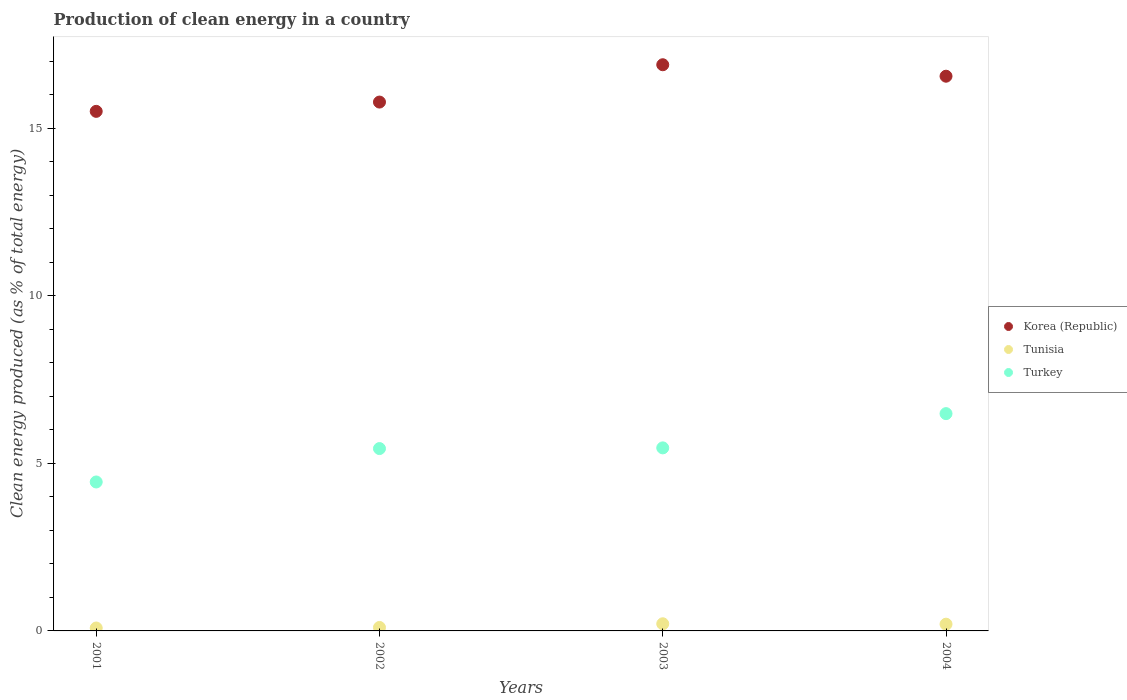How many different coloured dotlines are there?
Offer a terse response. 3. Is the number of dotlines equal to the number of legend labels?
Your response must be concise. Yes. What is the percentage of clean energy produced in Turkey in 2002?
Make the answer very short. 5.44. Across all years, what is the maximum percentage of clean energy produced in Turkey?
Offer a very short reply. 6.48. Across all years, what is the minimum percentage of clean energy produced in Korea (Republic)?
Offer a terse response. 15.5. In which year was the percentage of clean energy produced in Tunisia minimum?
Keep it short and to the point. 2001. What is the total percentage of clean energy produced in Turkey in the graph?
Keep it short and to the point. 21.83. What is the difference between the percentage of clean energy produced in Korea (Republic) in 2002 and that in 2004?
Make the answer very short. -0.77. What is the difference between the percentage of clean energy produced in Turkey in 2002 and the percentage of clean energy produced in Tunisia in 2001?
Provide a succinct answer. 5.35. What is the average percentage of clean energy produced in Tunisia per year?
Ensure brevity in your answer.  0.15. In the year 2003, what is the difference between the percentage of clean energy produced in Turkey and percentage of clean energy produced in Korea (Republic)?
Your answer should be compact. -11.43. What is the ratio of the percentage of clean energy produced in Turkey in 2001 to that in 2002?
Your answer should be very brief. 0.82. Is the percentage of clean energy produced in Tunisia in 2001 less than that in 2004?
Make the answer very short. Yes. What is the difference between the highest and the second highest percentage of clean energy produced in Turkey?
Offer a terse response. 1.02. What is the difference between the highest and the lowest percentage of clean energy produced in Tunisia?
Give a very brief answer. 0.13. Does the percentage of clean energy produced in Tunisia monotonically increase over the years?
Ensure brevity in your answer.  No. Is the percentage of clean energy produced in Turkey strictly greater than the percentage of clean energy produced in Korea (Republic) over the years?
Ensure brevity in your answer.  No. Is the percentage of clean energy produced in Tunisia strictly less than the percentage of clean energy produced in Turkey over the years?
Give a very brief answer. Yes. How many dotlines are there?
Give a very brief answer. 3. What is the title of the graph?
Give a very brief answer. Production of clean energy in a country. What is the label or title of the X-axis?
Provide a succinct answer. Years. What is the label or title of the Y-axis?
Provide a succinct answer. Clean energy produced (as % of total energy). What is the Clean energy produced (as % of total energy) of Korea (Republic) in 2001?
Provide a short and direct response. 15.5. What is the Clean energy produced (as % of total energy) in Tunisia in 2001?
Give a very brief answer. 0.09. What is the Clean energy produced (as % of total energy) in Turkey in 2001?
Offer a very short reply. 4.44. What is the Clean energy produced (as % of total energy) of Korea (Republic) in 2002?
Make the answer very short. 15.78. What is the Clean energy produced (as % of total energy) in Tunisia in 2002?
Offer a terse response. 0.1. What is the Clean energy produced (as % of total energy) of Turkey in 2002?
Your answer should be compact. 5.44. What is the Clean energy produced (as % of total energy) of Korea (Republic) in 2003?
Offer a terse response. 16.89. What is the Clean energy produced (as % of total energy) in Tunisia in 2003?
Provide a short and direct response. 0.21. What is the Clean energy produced (as % of total energy) in Turkey in 2003?
Offer a very short reply. 5.46. What is the Clean energy produced (as % of total energy) of Korea (Republic) in 2004?
Make the answer very short. 16.55. What is the Clean energy produced (as % of total energy) of Tunisia in 2004?
Offer a very short reply. 0.2. What is the Clean energy produced (as % of total energy) of Turkey in 2004?
Your answer should be very brief. 6.48. Across all years, what is the maximum Clean energy produced (as % of total energy) in Korea (Republic)?
Offer a very short reply. 16.89. Across all years, what is the maximum Clean energy produced (as % of total energy) of Tunisia?
Keep it short and to the point. 0.21. Across all years, what is the maximum Clean energy produced (as % of total energy) in Turkey?
Offer a very short reply. 6.48. Across all years, what is the minimum Clean energy produced (as % of total energy) in Korea (Republic)?
Give a very brief answer. 15.5. Across all years, what is the minimum Clean energy produced (as % of total energy) of Tunisia?
Your answer should be very brief. 0.09. Across all years, what is the minimum Clean energy produced (as % of total energy) of Turkey?
Offer a very short reply. 4.44. What is the total Clean energy produced (as % of total energy) of Korea (Republic) in the graph?
Give a very brief answer. 64.73. What is the total Clean energy produced (as % of total energy) in Tunisia in the graph?
Offer a very short reply. 0.6. What is the total Clean energy produced (as % of total energy) of Turkey in the graph?
Your answer should be compact. 21.83. What is the difference between the Clean energy produced (as % of total energy) in Korea (Republic) in 2001 and that in 2002?
Your answer should be very brief. -0.28. What is the difference between the Clean energy produced (as % of total energy) in Tunisia in 2001 and that in 2002?
Provide a succinct answer. -0.02. What is the difference between the Clean energy produced (as % of total energy) of Turkey in 2001 and that in 2002?
Ensure brevity in your answer.  -1. What is the difference between the Clean energy produced (as % of total energy) of Korea (Republic) in 2001 and that in 2003?
Your answer should be very brief. -1.39. What is the difference between the Clean energy produced (as % of total energy) in Tunisia in 2001 and that in 2003?
Give a very brief answer. -0.13. What is the difference between the Clean energy produced (as % of total energy) in Turkey in 2001 and that in 2003?
Your response must be concise. -1.02. What is the difference between the Clean energy produced (as % of total energy) in Korea (Republic) in 2001 and that in 2004?
Ensure brevity in your answer.  -1.05. What is the difference between the Clean energy produced (as % of total energy) in Tunisia in 2001 and that in 2004?
Keep it short and to the point. -0.11. What is the difference between the Clean energy produced (as % of total energy) of Turkey in 2001 and that in 2004?
Ensure brevity in your answer.  -2.04. What is the difference between the Clean energy produced (as % of total energy) in Korea (Republic) in 2002 and that in 2003?
Give a very brief answer. -1.11. What is the difference between the Clean energy produced (as % of total energy) in Tunisia in 2002 and that in 2003?
Offer a terse response. -0.11. What is the difference between the Clean energy produced (as % of total energy) of Turkey in 2002 and that in 2003?
Offer a terse response. -0.02. What is the difference between the Clean energy produced (as % of total energy) in Korea (Republic) in 2002 and that in 2004?
Keep it short and to the point. -0.77. What is the difference between the Clean energy produced (as % of total energy) in Tunisia in 2002 and that in 2004?
Ensure brevity in your answer.  -0.1. What is the difference between the Clean energy produced (as % of total energy) in Turkey in 2002 and that in 2004?
Keep it short and to the point. -1.04. What is the difference between the Clean energy produced (as % of total energy) in Korea (Republic) in 2003 and that in 2004?
Provide a succinct answer. 0.34. What is the difference between the Clean energy produced (as % of total energy) in Tunisia in 2003 and that in 2004?
Offer a very short reply. 0.01. What is the difference between the Clean energy produced (as % of total energy) in Turkey in 2003 and that in 2004?
Keep it short and to the point. -1.02. What is the difference between the Clean energy produced (as % of total energy) in Korea (Republic) in 2001 and the Clean energy produced (as % of total energy) in Tunisia in 2002?
Your answer should be compact. 15.4. What is the difference between the Clean energy produced (as % of total energy) in Korea (Republic) in 2001 and the Clean energy produced (as % of total energy) in Turkey in 2002?
Provide a short and direct response. 10.06. What is the difference between the Clean energy produced (as % of total energy) in Tunisia in 2001 and the Clean energy produced (as % of total energy) in Turkey in 2002?
Your answer should be very brief. -5.35. What is the difference between the Clean energy produced (as % of total energy) in Korea (Republic) in 2001 and the Clean energy produced (as % of total energy) in Tunisia in 2003?
Offer a very short reply. 15.29. What is the difference between the Clean energy produced (as % of total energy) of Korea (Republic) in 2001 and the Clean energy produced (as % of total energy) of Turkey in 2003?
Give a very brief answer. 10.04. What is the difference between the Clean energy produced (as % of total energy) of Tunisia in 2001 and the Clean energy produced (as % of total energy) of Turkey in 2003?
Provide a succinct answer. -5.37. What is the difference between the Clean energy produced (as % of total energy) in Korea (Republic) in 2001 and the Clean energy produced (as % of total energy) in Tunisia in 2004?
Provide a short and direct response. 15.3. What is the difference between the Clean energy produced (as % of total energy) of Korea (Republic) in 2001 and the Clean energy produced (as % of total energy) of Turkey in 2004?
Your answer should be very brief. 9.02. What is the difference between the Clean energy produced (as % of total energy) of Tunisia in 2001 and the Clean energy produced (as % of total energy) of Turkey in 2004?
Ensure brevity in your answer.  -6.4. What is the difference between the Clean energy produced (as % of total energy) in Korea (Republic) in 2002 and the Clean energy produced (as % of total energy) in Tunisia in 2003?
Provide a succinct answer. 15.57. What is the difference between the Clean energy produced (as % of total energy) of Korea (Republic) in 2002 and the Clean energy produced (as % of total energy) of Turkey in 2003?
Make the answer very short. 10.32. What is the difference between the Clean energy produced (as % of total energy) of Tunisia in 2002 and the Clean energy produced (as % of total energy) of Turkey in 2003?
Your answer should be compact. -5.36. What is the difference between the Clean energy produced (as % of total energy) in Korea (Republic) in 2002 and the Clean energy produced (as % of total energy) in Tunisia in 2004?
Offer a very short reply. 15.58. What is the difference between the Clean energy produced (as % of total energy) in Korea (Republic) in 2002 and the Clean energy produced (as % of total energy) in Turkey in 2004?
Provide a short and direct response. 9.3. What is the difference between the Clean energy produced (as % of total energy) of Tunisia in 2002 and the Clean energy produced (as % of total energy) of Turkey in 2004?
Give a very brief answer. -6.38. What is the difference between the Clean energy produced (as % of total energy) of Korea (Republic) in 2003 and the Clean energy produced (as % of total energy) of Tunisia in 2004?
Keep it short and to the point. 16.69. What is the difference between the Clean energy produced (as % of total energy) of Korea (Republic) in 2003 and the Clean energy produced (as % of total energy) of Turkey in 2004?
Ensure brevity in your answer.  10.41. What is the difference between the Clean energy produced (as % of total energy) of Tunisia in 2003 and the Clean energy produced (as % of total energy) of Turkey in 2004?
Your response must be concise. -6.27. What is the average Clean energy produced (as % of total energy) of Korea (Republic) per year?
Provide a short and direct response. 16.18. What is the average Clean energy produced (as % of total energy) in Tunisia per year?
Provide a succinct answer. 0.15. What is the average Clean energy produced (as % of total energy) of Turkey per year?
Ensure brevity in your answer.  5.46. In the year 2001, what is the difference between the Clean energy produced (as % of total energy) in Korea (Republic) and Clean energy produced (as % of total energy) in Tunisia?
Ensure brevity in your answer.  15.42. In the year 2001, what is the difference between the Clean energy produced (as % of total energy) in Korea (Republic) and Clean energy produced (as % of total energy) in Turkey?
Ensure brevity in your answer.  11.06. In the year 2001, what is the difference between the Clean energy produced (as % of total energy) of Tunisia and Clean energy produced (as % of total energy) of Turkey?
Give a very brief answer. -4.36. In the year 2002, what is the difference between the Clean energy produced (as % of total energy) of Korea (Republic) and Clean energy produced (as % of total energy) of Tunisia?
Your answer should be very brief. 15.68. In the year 2002, what is the difference between the Clean energy produced (as % of total energy) of Korea (Republic) and Clean energy produced (as % of total energy) of Turkey?
Give a very brief answer. 10.34. In the year 2002, what is the difference between the Clean energy produced (as % of total energy) of Tunisia and Clean energy produced (as % of total energy) of Turkey?
Keep it short and to the point. -5.34. In the year 2003, what is the difference between the Clean energy produced (as % of total energy) of Korea (Republic) and Clean energy produced (as % of total energy) of Tunisia?
Offer a very short reply. 16.68. In the year 2003, what is the difference between the Clean energy produced (as % of total energy) in Korea (Republic) and Clean energy produced (as % of total energy) in Turkey?
Provide a short and direct response. 11.43. In the year 2003, what is the difference between the Clean energy produced (as % of total energy) of Tunisia and Clean energy produced (as % of total energy) of Turkey?
Make the answer very short. -5.25. In the year 2004, what is the difference between the Clean energy produced (as % of total energy) in Korea (Republic) and Clean energy produced (as % of total energy) in Tunisia?
Your response must be concise. 16.35. In the year 2004, what is the difference between the Clean energy produced (as % of total energy) of Korea (Republic) and Clean energy produced (as % of total energy) of Turkey?
Make the answer very short. 10.07. In the year 2004, what is the difference between the Clean energy produced (as % of total energy) of Tunisia and Clean energy produced (as % of total energy) of Turkey?
Provide a succinct answer. -6.28. What is the ratio of the Clean energy produced (as % of total energy) of Korea (Republic) in 2001 to that in 2002?
Your response must be concise. 0.98. What is the ratio of the Clean energy produced (as % of total energy) of Tunisia in 2001 to that in 2002?
Your answer should be compact. 0.84. What is the ratio of the Clean energy produced (as % of total energy) in Turkey in 2001 to that in 2002?
Offer a very short reply. 0.82. What is the ratio of the Clean energy produced (as % of total energy) in Korea (Republic) in 2001 to that in 2003?
Provide a succinct answer. 0.92. What is the ratio of the Clean energy produced (as % of total energy) in Tunisia in 2001 to that in 2003?
Keep it short and to the point. 0.41. What is the ratio of the Clean energy produced (as % of total energy) of Turkey in 2001 to that in 2003?
Ensure brevity in your answer.  0.81. What is the ratio of the Clean energy produced (as % of total energy) of Korea (Republic) in 2001 to that in 2004?
Provide a short and direct response. 0.94. What is the ratio of the Clean energy produced (as % of total energy) in Tunisia in 2001 to that in 2004?
Make the answer very short. 0.43. What is the ratio of the Clean energy produced (as % of total energy) of Turkey in 2001 to that in 2004?
Your answer should be compact. 0.69. What is the ratio of the Clean energy produced (as % of total energy) in Korea (Republic) in 2002 to that in 2003?
Offer a very short reply. 0.93. What is the ratio of the Clean energy produced (as % of total energy) of Tunisia in 2002 to that in 2003?
Make the answer very short. 0.49. What is the ratio of the Clean energy produced (as % of total energy) of Korea (Republic) in 2002 to that in 2004?
Ensure brevity in your answer.  0.95. What is the ratio of the Clean energy produced (as % of total energy) in Tunisia in 2002 to that in 2004?
Ensure brevity in your answer.  0.51. What is the ratio of the Clean energy produced (as % of total energy) of Turkey in 2002 to that in 2004?
Give a very brief answer. 0.84. What is the ratio of the Clean energy produced (as % of total energy) of Korea (Republic) in 2003 to that in 2004?
Make the answer very short. 1.02. What is the ratio of the Clean energy produced (as % of total energy) of Tunisia in 2003 to that in 2004?
Your answer should be very brief. 1.06. What is the ratio of the Clean energy produced (as % of total energy) in Turkey in 2003 to that in 2004?
Offer a very short reply. 0.84. What is the difference between the highest and the second highest Clean energy produced (as % of total energy) in Korea (Republic)?
Offer a terse response. 0.34. What is the difference between the highest and the second highest Clean energy produced (as % of total energy) of Tunisia?
Provide a succinct answer. 0.01. What is the difference between the highest and the second highest Clean energy produced (as % of total energy) of Turkey?
Keep it short and to the point. 1.02. What is the difference between the highest and the lowest Clean energy produced (as % of total energy) of Korea (Republic)?
Your response must be concise. 1.39. What is the difference between the highest and the lowest Clean energy produced (as % of total energy) in Tunisia?
Keep it short and to the point. 0.13. What is the difference between the highest and the lowest Clean energy produced (as % of total energy) in Turkey?
Offer a very short reply. 2.04. 